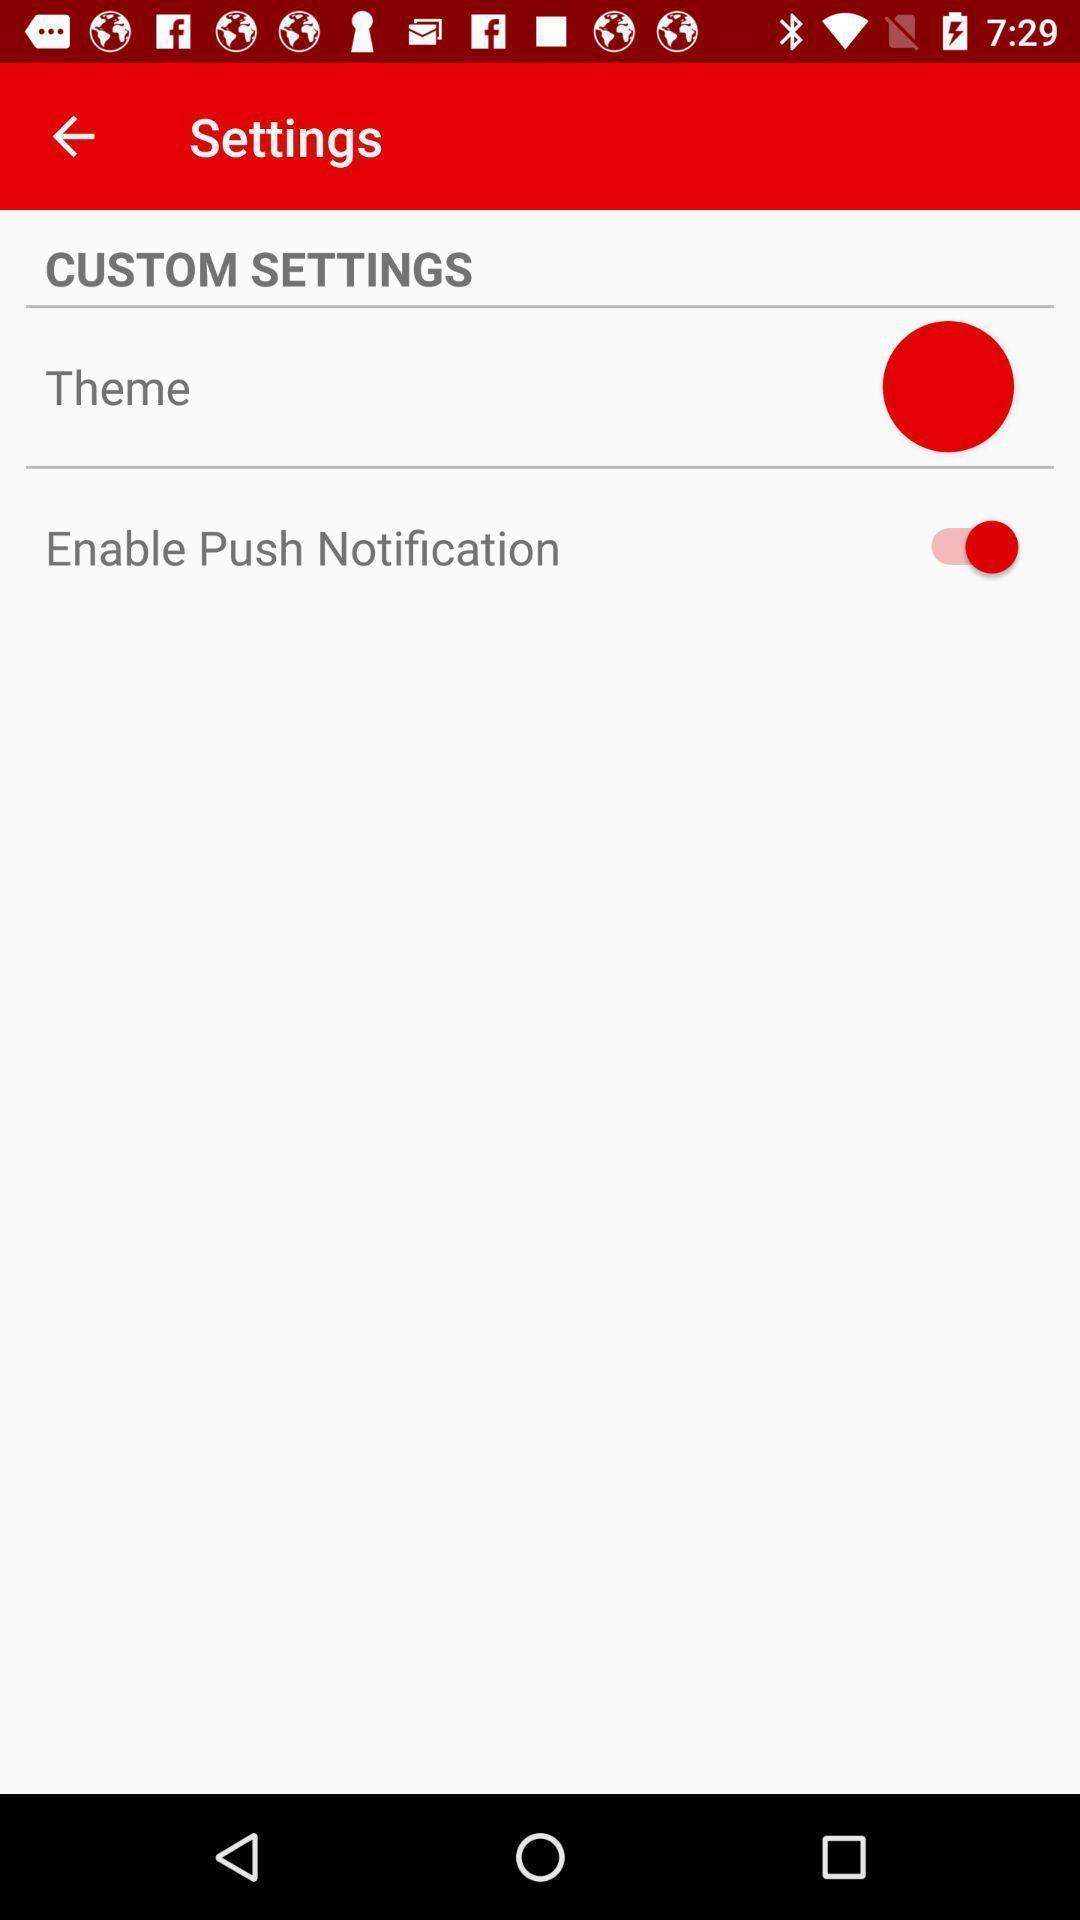What is the overall content of this screenshot? Settings page. 